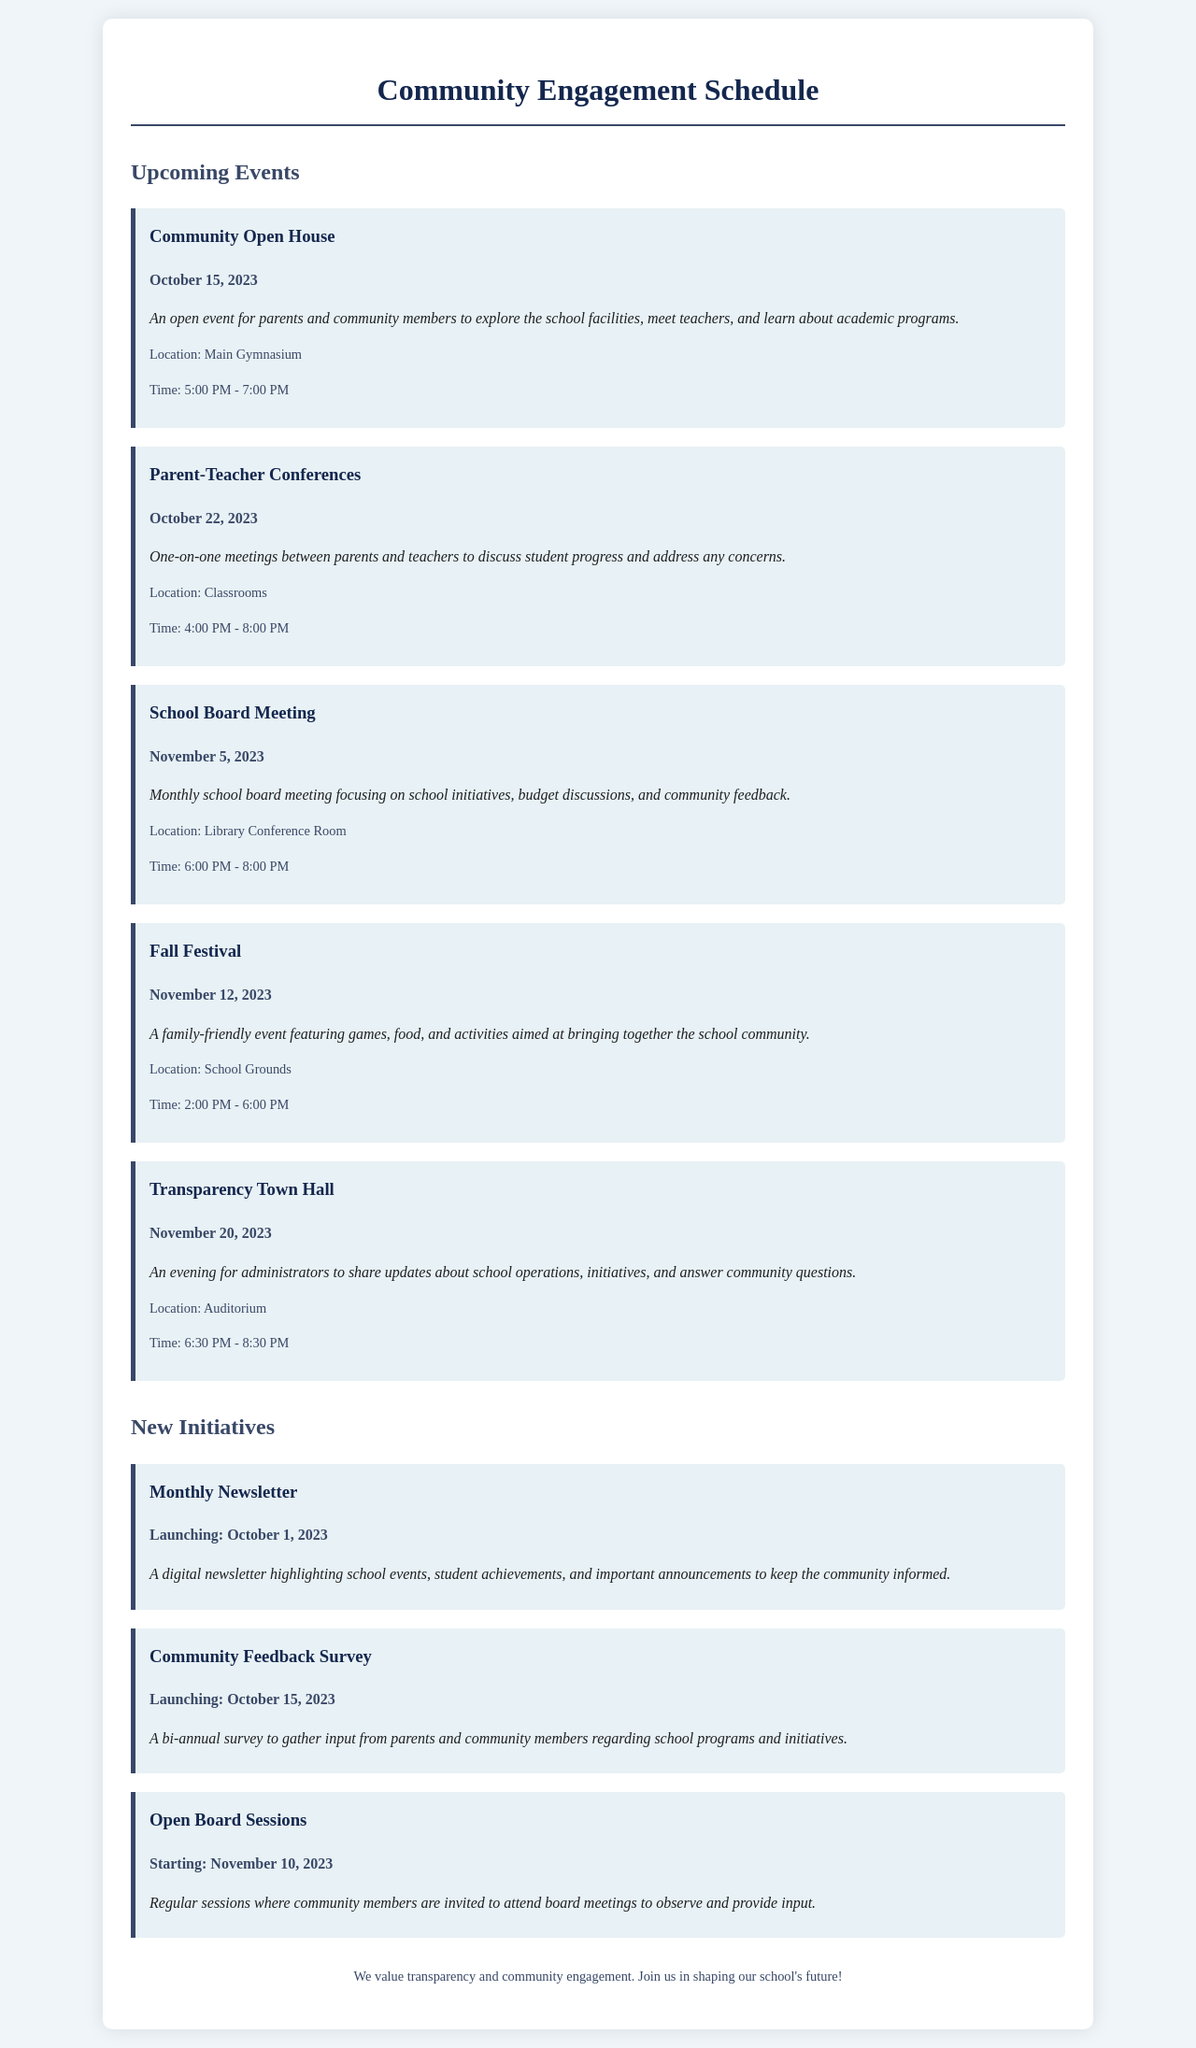What is the date of the Community Open House? The date is specified under the event, which states it will be held on October 15, 2023.
Answer: October 15, 2023 What time does the Fall Festival start? The permitted time for the Fall Festival is mentioned in the event details, which indicates it starts at 2:00 PM.
Answer: 2:00 PM Where will the Transparency Town Hall take place? The location for the Transparency Town Hall is listed in the event details; it states the Auditorium is the venue.
Answer: Auditorium How many new initiatives are listed in the document? The document contains three new initiatives as stated in the New Initiatives section.
Answer: 3 What is the purpose of the Community Feedback Survey? The description of the Community Feedback Survey explains it's to gather input from parents and community members.
Answer: Gather input What is the name of the event occurring on November 5, 2023? The document specifies that the event on this date is the School Board Meeting.
Answer: School Board Meeting When do the Open Board Sessions start? The document clearly states that Open Board Sessions will begin on November 10, 2023.
Answer: November 10, 2023 What specific type of event is the Fall Festival? The description of the Fall Festival indicates it is a family-friendly event.
Answer: Family-friendly event When was the Monthly Newsletter launched? The document clearly states that the Monthly Newsletter launched on October 1, 2023.
Answer: October 1, 2023 